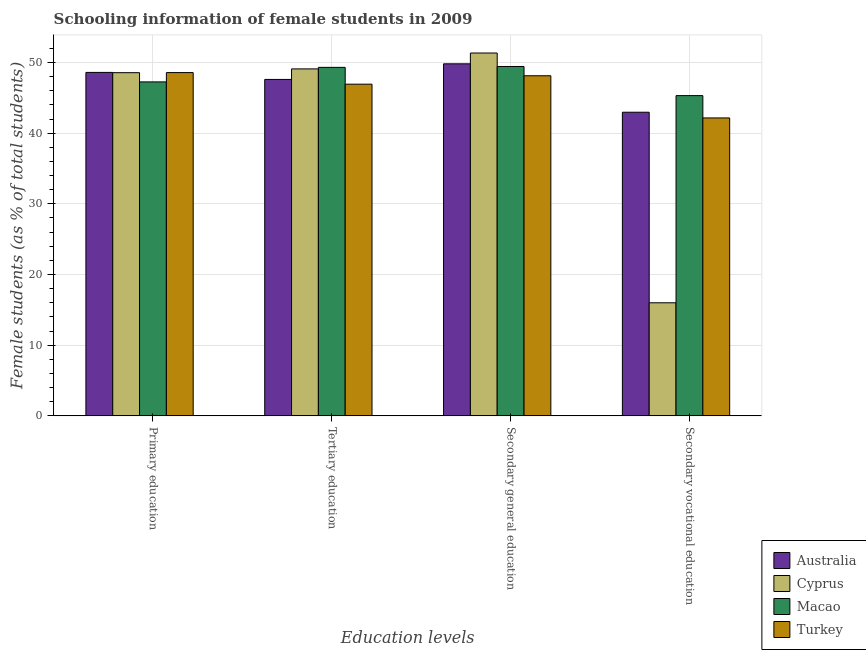How many groups of bars are there?
Your answer should be very brief. 4. Are the number of bars per tick equal to the number of legend labels?
Offer a terse response. Yes. How many bars are there on the 2nd tick from the right?
Your answer should be very brief. 4. What is the label of the 2nd group of bars from the left?
Offer a terse response. Tertiary education. What is the percentage of female students in secondary vocational education in Macao?
Provide a short and direct response. 45.32. Across all countries, what is the maximum percentage of female students in secondary education?
Ensure brevity in your answer.  51.34. Across all countries, what is the minimum percentage of female students in secondary education?
Your response must be concise. 48.13. In which country was the percentage of female students in primary education maximum?
Your response must be concise. Australia. In which country was the percentage of female students in tertiary education minimum?
Offer a very short reply. Turkey. What is the total percentage of female students in primary education in the graph?
Make the answer very short. 193. What is the difference between the percentage of female students in primary education in Cyprus and that in Turkey?
Keep it short and to the point. -0.01. What is the difference between the percentage of female students in secondary education in Macao and the percentage of female students in secondary vocational education in Cyprus?
Provide a succinct answer. 33.44. What is the average percentage of female students in primary education per country?
Ensure brevity in your answer.  48.25. What is the difference between the percentage of female students in tertiary education and percentage of female students in primary education in Australia?
Your answer should be compact. -0.99. What is the ratio of the percentage of female students in secondary education in Turkey to that in Cyprus?
Your response must be concise. 0.94. Is the difference between the percentage of female students in secondary education in Cyprus and Turkey greater than the difference between the percentage of female students in primary education in Cyprus and Turkey?
Your answer should be very brief. Yes. What is the difference between the highest and the second highest percentage of female students in secondary education?
Provide a succinct answer. 1.53. What is the difference between the highest and the lowest percentage of female students in primary education?
Give a very brief answer. 1.34. Is the sum of the percentage of female students in tertiary education in Australia and Turkey greater than the maximum percentage of female students in secondary education across all countries?
Provide a short and direct response. Yes. What does the 4th bar from the left in Tertiary education represents?
Provide a succinct answer. Turkey. What does the 3rd bar from the right in Secondary general education represents?
Provide a short and direct response. Cyprus. What is the difference between two consecutive major ticks on the Y-axis?
Make the answer very short. 10. Where does the legend appear in the graph?
Ensure brevity in your answer.  Bottom right. How are the legend labels stacked?
Ensure brevity in your answer.  Vertical. What is the title of the graph?
Keep it short and to the point. Schooling information of female students in 2009. What is the label or title of the X-axis?
Keep it short and to the point. Education levels. What is the label or title of the Y-axis?
Your answer should be very brief. Female students (as % of total students). What is the Female students (as % of total students) of Australia in Primary education?
Give a very brief answer. 48.6. What is the Female students (as % of total students) in Cyprus in Primary education?
Provide a succinct answer. 48.56. What is the Female students (as % of total students) in Macao in Primary education?
Keep it short and to the point. 47.26. What is the Female students (as % of total students) in Turkey in Primary education?
Give a very brief answer. 48.58. What is the Female students (as % of total students) of Australia in Tertiary education?
Ensure brevity in your answer.  47.61. What is the Female students (as % of total students) of Cyprus in Tertiary education?
Ensure brevity in your answer.  49.1. What is the Female students (as % of total students) in Macao in Tertiary education?
Offer a very short reply. 49.31. What is the Female students (as % of total students) of Turkey in Tertiary education?
Make the answer very short. 46.93. What is the Female students (as % of total students) in Australia in Secondary general education?
Provide a succinct answer. 49.82. What is the Female students (as % of total students) in Cyprus in Secondary general education?
Provide a short and direct response. 51.34. What is the Female students (as % of total students) in Macao in Secondary general education?
Your response must be concise. 49.44. What is the Female students (as % of total students) of Turkey in Secondary general education?
Your response must be concise. 48.13. What is the Female students (as % of total students) in Australia in Secondary vocational education?
Ensure brevity in your answer.  42.97. What is the Female students (as % of total students) in Cyprus in Secondary vocational education?
Keep it short and to the point. 16. What is the Female students (as % of total students) in Macao in Secondary vocational education?
Provide a short and direct response. 45.32. What is the Female students (as % of total students) in Turkey in Secondary vocational education?
Keep it short and to the point. 42.16. Across all Education levels, what is the maximum Female students (as % of total students) of Australia?
Offer a very short reply. 49.82. Across all Education levels, what is the maximum Female students (as % of total students) in Cyprus?
Your answer should be compact. 51.34. Across all Education levels, what is the maximum Female students (as % of total students) of Macao?
Offer a terse response. 49.44. Across all Education levels, what is the maximum Female students (as % of total students) in Turkey?
Keep it short and to the point. 48.58. Across all Education levels, what is the minimum Female students (as % of total students) of Australia?
Ensure brevity in your answer.  42.97. Across all Education levels, what is the minimum Female students (as % of total students) of Cyprus?
Offer a terse response. 16. Across all Education levels, what is the minimum Female students (as % of total students) of Macao?
Keep it short and to the point. 45.32. Across all Education levels, what is the minimum Female students (as % of total students) in Turkey?
Provide a short and direct response. 42.16. What is the total Female students (as % of total students) of Australia in the graph?
Provide a succinct answer. 188.99. What is the total Female students (as % of total students) of Cyprus in the graph?
Provide a succinct answer. 165. What is the total Female students (as % of total students) in Macao in the graph?
Give a very brief answer. 191.33. What is the total Female students (as % of total students) in Turkey in the graph?
Give a very brief answer. 185.79. What is the difference between the Female students (as % of total students) of Australia in Primary education and that in Tertiary education?
Give a very brief answer. 0.99. What is the difference between the Female students (as % of total students) in Cyprus in Primary education and that in Tertiary education?
Provide a short and direct response. -0.53. What is the difference between the Female students (as % of total students) of Macao in Primary education and that in Tertiary education?
Keep it short and to the point. -2.06. What is the difference between the Female students (as % of total students) of Turkey in Primary education and that in Tertiary education?
Your answer should be very brief. 1.64. What is the difference between the Female students (as % of total students) of Australia in Primary education and that in Secondary general education?
Your answer should be very brief. -1.22. What is the difference between the Female students (as % of total students) in Cyprus in Primary education and that in Secondary general education?
Keep it short and to the point. -2.78. What is the difference between the Female students (as % of total students) in Macao in Primary education and that in Secondary general education?
Your answer should be very brief. -2.18. What is the difference between the Female students (as % of total students) of Turkey in Primary education and that in Secondary general education?
Give a very brief answer. 0.45. What is the difference between the Female students (as % of total students) in Australia in Primary education and that in Secondary vocational education?
Your response must be concise. 5.63. What is the difference between the Female students (as % of total students) in Cyprus in Primary education and that in Secondary vocational education?
Offer a very short reply. 32.56. What is the difference between the Female students (as % of total students) of Macao in Primary education and that in Secondary vocational education?
Your answer should be very brief. 1.94. What is the difference between the Female students (as % of total students) in Turkey in Primary education and that in Secondary vocational education?
Provide a short and direct response. 6.42. What is the difference between the Female students (as % of total students) in Australia in Tertiary education and that in Secondary general education?
Provide a succinct answer. -2.21. What is the difference between the Female students (as % of total students) in Cyprus in Tertiary education and that in Secondary general education?
Offer a very short reply. -2.25. What is the difference between the Female students (as % of total students) in Macao in Tertiary education and that in Secondary general education?
Offer a very short reply. -0.12. What is the difference between the Female students (as % of total students) in Turkey in Tertiary education and that in Secondary general education?
Offer a very short reply. -1.19. What is the difference between the Female students (as % of total students) of Australia in Tertiary education and that in Secondary vocational education?
Make the answer very short. 4.64. What is the difference between the Female students (as % of total students) in Cyprus in Tertiary education and that in Secondary vocational education?
Your answer should be compact. 33.1. What is the difference between the Female students (as % of total students) in Macao in Tertiary education and that in Secondary vocational education?
Ensure brevity in your answer.  4. What is the difference between the Female students (as % of total students) in Turkey in Tertiary education and that in Secondary vocational education?
Offer a terse response. 4.78. What is the difference between the Female students (as % of total students) in Australia in Secondary general education and that in Secondary vocational education?
Make the answer very short. 6.85. What is the difference between the Female students (as % of total students) of Cyprus in Secondary general education and that in Secondary vocational education?
Ensure brevity in your answer.  35.34. What is the difference between the Female students (as % of total students) of Macao in Secondary general education and that in Secondary vocational education?
Provide a succinct answer. 4.12. What is the difference between the Female students (as % of total students) of Turkey in Secondary general education and that in Secondary vocational education?
Ensure brevity in your answer.  5.97. What is the difference between the Female students (as % of total students) in Australia in Primary education and the Female students (as % of total students) in Cyprus in Tertiary education?
Your response must be concise. -0.5. What is the difference between the Female students (as % of total students) in Australia in Primary education and the Female students (as % of total students) in Macao in Tertiary education?
Your response must be concise. -0.71. What is the difference between the Female students (as % of total students) of Australia in Primary education and the Female students (as % of total students) of Turkey in Tertiary education?
Provide a succinct answer. 1.67. What is the difference between the Female students (as % of total students) of Cyprus in Primary education and the Female students (as % of total students) of Macao in Tertiary education?
Provide a succinct answer. -0.75. What is the difference between the Female students (as % of total students) in Cyprus in Primary education and the Female students (as % of total students) in Turkey in Tertiary education?
Provide a short and direct response. 1.63. What is the difference between the Female students (as % of total students) of Macao in Primary education and the Female students (as % of total students) of Turkey in Tertiary education?
Ensure brevity in your answer.  0.32. What is the difference between the Female students (as % of total students) of Australia in Primary education and the Female students (as % of total students) of Cyprus in Secondary general education?
Provide a succinct answer. -2.74. What is the difference between the Female students (as % of total students) of Australia in Primary education and the Female students (as % of total students) of Macao in Secondary general education?
Your answer should be very brief. -0.84. What is the difference between the Female students (as % of total students) of Australia in Primary education and the Female students (as % of total students) of Turkey in Secondary general education?
Provide a short and direct response. 0.47. What is the difference between the Female students (as % of total students) of Cyprus in Primary education and the Female students (as % of total students) of Macao in Secondary general education?
Provide a short and direct response. -0.87. What is the difference between the Female students (as % of total students) of Cyprus in Primary education and the Female students (as % of total students) of Turkey in Secondary general education?
Provide a short and direct response. 0.44. What is the difference between the Female students (as % of total students) of Macao in Primary education and the Female students (as % of total students) of Turkey in Secondary general education?
Provide a short and direct response. -0.87. What is the difference between the Female students (as % of total students) in Australia in Primary education and the Female students (as % of total students) in Cyprus in Secondary vocational education?
Provide a succinct answer. 32.6. What is the difference between the Female students (as % of total students) of Australia in Primary education and the Female students (as % of total students) of Macao in Secondary vocational education?
Offer a very short reply. 3.28. What is the difference between the Female students (as % of total students) of Australia in Primary education and the Female students (as % of total students) of Turkey in Secondary vocational education?
Keep it short and to the point. 6.44. What is the difference between the Female students (as % of total students) of Cyprus in Primary education and the Female students (as % of total students) of Macao in Secondary vocational education?
Offer a terse response. 3.25. What is the difference between the Female students (as % of total students) of Cyprus in Primary education and the Female students (as % of total students) of Turkey in Secondary vocational education?
Provide a succinct answer. 6.4. What is the difference between the Female students (as % of total students) in Macao in Primary education and the Female students (as % of total students) in Turkey in Secondary vocational education?
Offer a terse response. 5.1. What is the difference between the Female students (as % of total students) in Australia in Tertiary education and the Female students (as % of total students) in Cyprus in Secondary general education?
Make the answer very short. -3.74. What is the difference between the Female students (as % of total students) of Australia in Tertiary education and the Female students (as % of total students) of Macao in Secondary general education?
Provide a succinct answer. -1.83. What is the difference between the Female students (as % of total students) in Australia in Tertiary education and the Female students (as % of total students) in Turkey in Secondary general education?
Give a very brief answer. -0.52. What is the difference between the Female students (as % of total students) in Cyprus in Tertiary education and the Female students (as % of total students) in Macao in Secondary general education?
Keep it short and to the point. -0.34. What is the difference between the Female students (as % of total students) of Cyprus in Tertiary education and the Female students (as % of total students) of Turkey in Secondary general education?
Provide a short and direct response. 0.97. What is the difference between the Female students (as % of total students) in Macao in Tertiary education and the Female students (as % of total students) in Turkey in Secondary general education?
Provide a succinct answer. 1.19. What is the difference between the Female students (as % of total students) of Australia in Tertiary education and the Female students (as % of total students) of Cyprus in Secondary vocational education?
Your answer should be very brief. 31.61. What is the difference between the Female students (as % of total students) in Australia in Tertiary education and the Female students (as % of total students) in Macao in Secondary vocational education?
Your answer should be compact. 2.29. What is the difference between the Female students (as % of total students) in Australia in Tertiary education and the Female students (as % of total students) in Turkey in Secondary vocational education?
Keep it short and to the point. 5.45. What is the difference between the Female students (as % of total students) of Cyprus in Tertiary education and the Female students (as % of total students) of Macao in Secondary vocational education?
Keep it short and to the point. 3.78. What is the difference between the Female students (as % of total students) in Cyprus in Tertiary education and the Female students (as % of total students) in Turkey in Secondary vocational education?
Provide a succinct answer. 6.94. What is the difference between the Female students (as % of total students) of Macao in Tertiary education and the Female students (as % of total students) of Turkey in Secondary vocational education?
Provide a short and direct response. 7.16. What is the difference between the Female students (as % of total students) in Australia in Secondary general education and the Female students (as % of total students) in Cyprus in Secondary vocational education?
Give a very brief answer. 33.82. What is the difference between the Female students (as % of total students) in Australia in Secondary general education and the Female students (as % of total students) in Macao in Secondary vocational education?
Make the answer very short. 4.5. What is the difference between the Female students (as % of total students) of Australia in Secondary general education and the Female students (as % of total students) of Turkey in Secondary vocational education?
Your answer should be compact. 7.66. What is the difference between the Female students (as % of total students) in Cyprus in Secondary general education and the Female students (as % of total students) in Macao in Secondary vocational education?
Offer a very short reply. 6.03. What is the difference between the Female students (as % of total students) of Cyprus in Secondary general education and the Female students (as % of total students) of Turkey in Secondary vocational education?
Provide a succinct answer. 9.19. What is the difference between the Female students (as % of total students) of Macao in Secondary general education and the Female students (as % of total students) of Turkey in Secondary vocational education?
Ensure brevity in your answer.  7.28. What is the average Female students (as % of total students) of Australia per Education levels?
Your response must be concise. 47.25. What is the average Female students (as % of total students) of Cyprus per Education levels?
Keep it short and to the point. 41.25. What is the average Female students (as % of total students) in Macao per Education levels?
Your answer should be compact. 47.83. What is the average Female students (as % of total students) of Turkey per Education levels?
Make the answer very short. 46.45. What is the difference between the Female students (as % of total students) in Australia and Female students (as % of total students) in Cyprus in Primary education?
Provide a short and direct response. 0.04. What is the difference between the Female students (as % of total students) of Australia and Female students (as % of total students) of Macao in Primary education?
Offer a terse response. 1.34. What is the difference between the Female students (as % of total students) in Australia and Female students (as % of total students) in Turkey in Primary education?
Keep it short and to the point. 0.02. What is the difference between the Female students (as % of total students) of Cyprus and Female students (as % of total students) of Macao in Primary education?
Offer a very short reply. 1.3. What is the difference between the Female students (as % of total students) in Cyprus and Female students (as % of total students) in Turkey in Primary education?
Your answer should be very brief. -0.01. What is the difference between the Female students (as % of total students) of Macao and Female students (as % of total students) of Turkey in Primary education?
Your answer should be compact. -1.32. What is the difference between the Female students (as % of total students) of Australia and Female students (as % of total students) of Cyprus in Tertiary education?
Keep it short and to the point. -1.49. What is the difference between the Female students (as % of total students) of Australia and Female students (as % of total students) of Macao in Tertiary education?
Ensure brevity in your answer.  -1.71. What is the difference between the Female students (as % of total students) in Australia and Female students (as % of total students) in Turkey in Tertiary education?
Make the answer very short. 0.67. What is the difference between the Female students (as % of total students) of Cyprus and Female students (as % of total students) of Macao in Tertiary education?
Your answer should be compact. -0.22. What is the difference between the Female students (as % of total students) in Cyprus and Female students (as % of total students) in Turkey in Tertiary education?
Provide a short and direct response. 2.16. What is the difference between the Female students (as % of total students) of Macao and Female students (as % of total students) of Turkey in Tertiary education?
Provide a short and direct response. 2.38. What is the difference between the Female students (as % of total students) in Australia and Female students (as % of total students) in Cyprus in Secondary general education?
Your answer should be very brief. -1.53. What is the difference between the Female students (as % of total students) in Australia and Female students (as % of total students) in Macao in Secondary general education?
Make the answer very short. 0.38. What is the difference between the Female students (as % of total students) of Australia and Female students (as % of total students) of Turkey in Secondary general education?
Give a very brief answer. 1.69. What is the difference between the Female students (as % of total students) in Cyprus and Female students (as % of total students) in Macao in Secondary general education?
Keep it short and to the point. 1.91. What is the difference between the Female students (as % of total students) in Cyprus and Female students (as % of total students) in Turkey in Secondary general education?
Offer a terse response. 3.22. What is the difference between the Female students (as % of total students) in Macao and Female students (as % of total students) in Turkey in Secondary general education?
Give a very brief answer. 1.31. What is the difference between the Female students (as % of total students) in Australia and Female students (as % of total students) in Cyprus in Secondary vocational education?
Make the answer very short. 26.96. What is the difference between the Female students (as % of total students) in Australia and Female students (as % of total students) in Macao in Secondary vocational education?
Your response must be concise. -2.35. What is the difference between the Female students (as % of total students) in Australia and Female students (as % of total students) in Turkey in Secondary vocational education?
Offer a very short reply. 0.81. What is the difference between the Female students (as % of total students) of Cyprus and Female students (as % of total students) of Macao in Secondary vocational education?
Your answer should be very brief. -29.32. What is the difference between the Female students (as % of total students) in Cyprus and Female students (as % of total students) in Turkey in Secondary vocational education?
Make the answer very short. -26.16. What is the difference between the Female students (as % of total students) in Macao and Female students (as % of total students) in Turkey in Secondary vocational education?
Keep it short and to the point. 3.16. What is the ratio of the Female students (as % of total students) of Australia in Primary education to that in Tertiary education?
Keep it short and to the point. 1.02. What is the ratio of the Female students (as % of total students) of Turkey in Primary education to that in Tertiary education?
Your answer should be very brief. 1.03. What is the ratio of the Female students (as % of total students) of Australia in Primary education to that in Secondary general education?
Your answer should be very brief. 0.98. What is the ratio of the Female students (as % of total students) of Cyprus in Primary education to that in Secondary general education?
Ensure brevity in your answer.  0.95. What is the ratio of the Female students (as % of total students) of Macao in Primary education to that in Secondary general education?
Offer a terse response. 0.96. What is the ratio of the Female students (as % of total students) of Turkey in Primary education to that in Secondary general education?
Make the answer very short. 1.01. What is the ratio of the Female students (as % of total students) in Australia in Primary education to that in Secondary vocational education?
Keep it short and to the point. 1.13. What is the ratio of the Female students (as % of total students) in Cyprus in Primary education to that in Secondary vocational education?
Your answer should be very brief. 3.04. What is the ratio of the Female students (as % of total students) of Macao in Primary education to that in Secondary vocational education?
Provide a succinct answer. 1.04. What is the ratio of the Female students (as % of total students) of Turkey in Primary education to that in Secondary vocational education?
Give a very brief answer. 1.15. What is the ratio of the Female students (as % of total students) in Australia in Tertiary education to that in Secondary general education?
Offer a very short reply. 0.96. What is the ratio of the Female students (as % of total students) of Cyprus in Tertiary education to that in Secondary general education?
Offer a very short reply. 0.96. What is the ratio of the Female students (as % of total students) in Macao in Tertiary education to that in Secondary general education?
Your answer should be compact. 1. What is the ratio of the Female students (as % of total students) of Turkey in Tertiary education to that in Secondary general education?
Your answer should be compact. 0.98. What is the ratio of the Female students (as % of total students) of Australia in Tertiary education to that in Secondary vocational education?
Offer a terse response. 1.11. What is the ratio of the Female students (as % of total students) of Cyprus in Tertiary education to that in Secondary vocational education?
Keep it short and to the point. 3.07. What is the ratio of the Female students (as % of total students) of Macao in Tertiary education to that in Secondary vocational education?
Provide a succinct answer. 1.09. What is the ratio of the Female students (as % of total students) in Turkey in Tertiary education to that in Secondary vocational education?
Give a very brief answer. 1.11. What is the ratio of the Female students (as % of total students) of Australia in Secondary general education to that in Secondary vocational education?
Ensure brevity in your answer.  1.16. What is the ratio of the Female students (as % of total students) in Cyprus in Secondary general education to that in Secondary vocational education?
Make the answer very short. 3.21. What is the ratio of the Female students (as % of total students) of Turkey in Secondary general education to that in Secondary vocational education?
Provide a succinct answer. 1.14. What is the difference between the highest and the second highest Female students (as % of total students) of Australia?
Provide a succinct answer. 1.22. What is the difference between the highest and the second highest Female students (as % of total students) of Cyprus?
Keep it short and to the point. 2.25. What is the difference between the highest and the second highest Female students (as % of total students) of Macao?
Give a very brief answer. 0.12. What is the difference between the highest and the second highest Female students (as % of total students) of Turkey?
Make the answer very short. 0.45. What is the difference between the highest and the lowest Female students (as % of total students) of Australia?
Keep it short and to the point. 6.85. What is the difference between the highest and the lowest Female students (as % of total students) in Cyprus?
Give a very brief answer. 35.34. What is the difference between the highest and the lowest Female students (as % of total students) in Macao?
Make the answer very short. 4.12. What is the difference between the highest and the lowest Female students (as % of total students) in Turkey?
Make the answer very short. 6.42. 